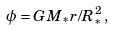Convert formula to latex. <formula><loc_0><loc_0><loc_500><loc_500>\phi = G M _ { * } r / R _ { * } ^ { 2 } \, ,</formula> 